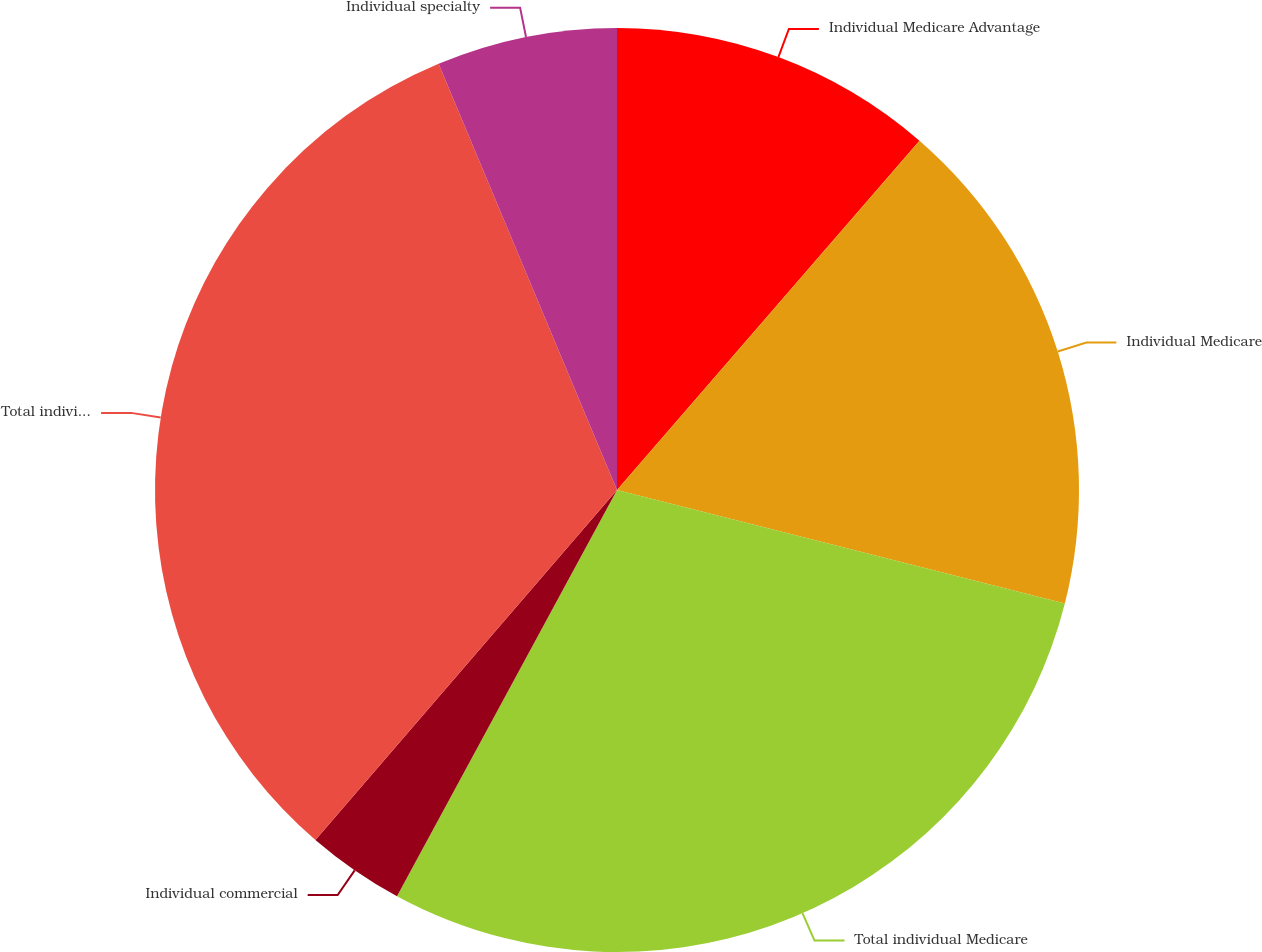Convert chart. <chart><loc_0><loc_0><loc_500><loc_500><pie_chart><fcel>Individual Medicare Advantage<fcel>Individual Medicare<fcel>Total individual Medicare<fcel>Individual commercial<fcel>Total individual medical<fcel>Individual specialty<nl><fcel>11.36%<fcel>17.59%<fcel>28.95%<fcel>3.42%<fcel>32.37%<fcel>6.31%<nl></chart> 